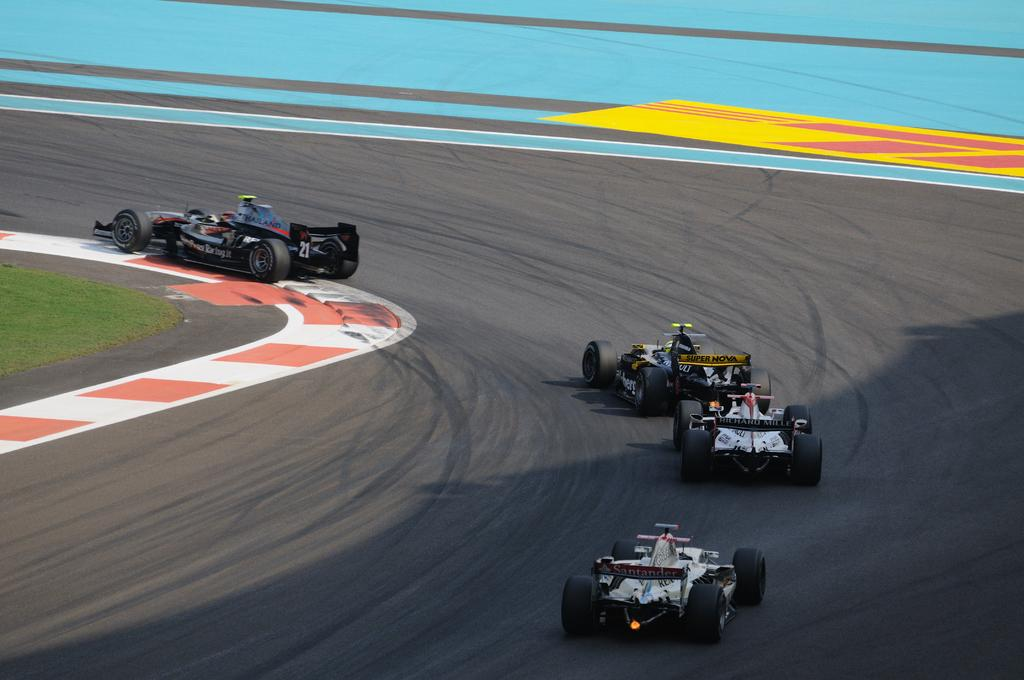How many cars can be seen on the road in the image? There are four cars on the road in the image. What is the main subject of the image? The image depicts a road. What type of vegetation is visible in the image? Grass is visible in the image. What type of dress is the grass wearing in the image? The grass is not wearing a dress in the image; it is a natural vegetation. 